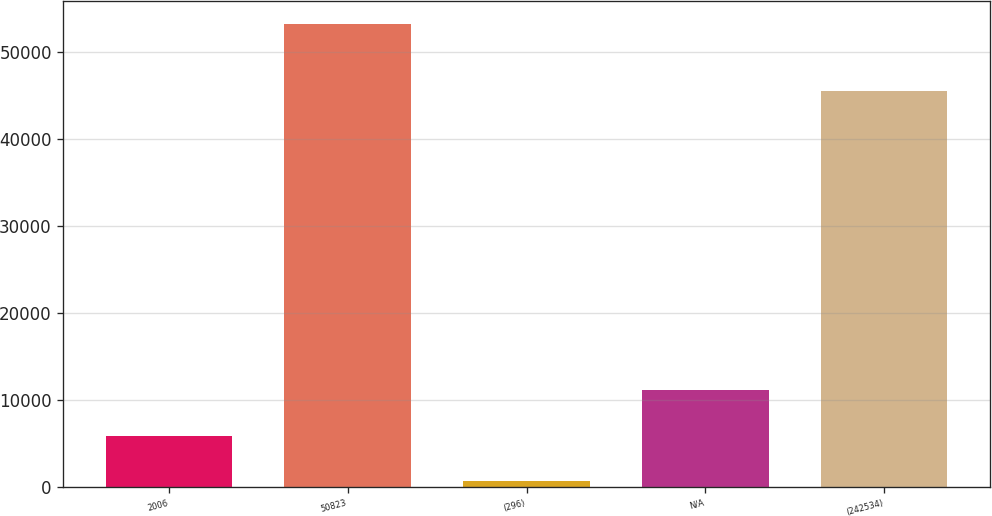<chart> <loc_0><loc_0><loc_500><loc_500><bar_chart><fcel>2006<fcel>50823<fcel>(296)<fcel>N/A<fcel>(242534)<nl><fcel>5872.6<fcel>53164<fcel>618<fcel>11127.2<fcel>45535<nl></chart> 